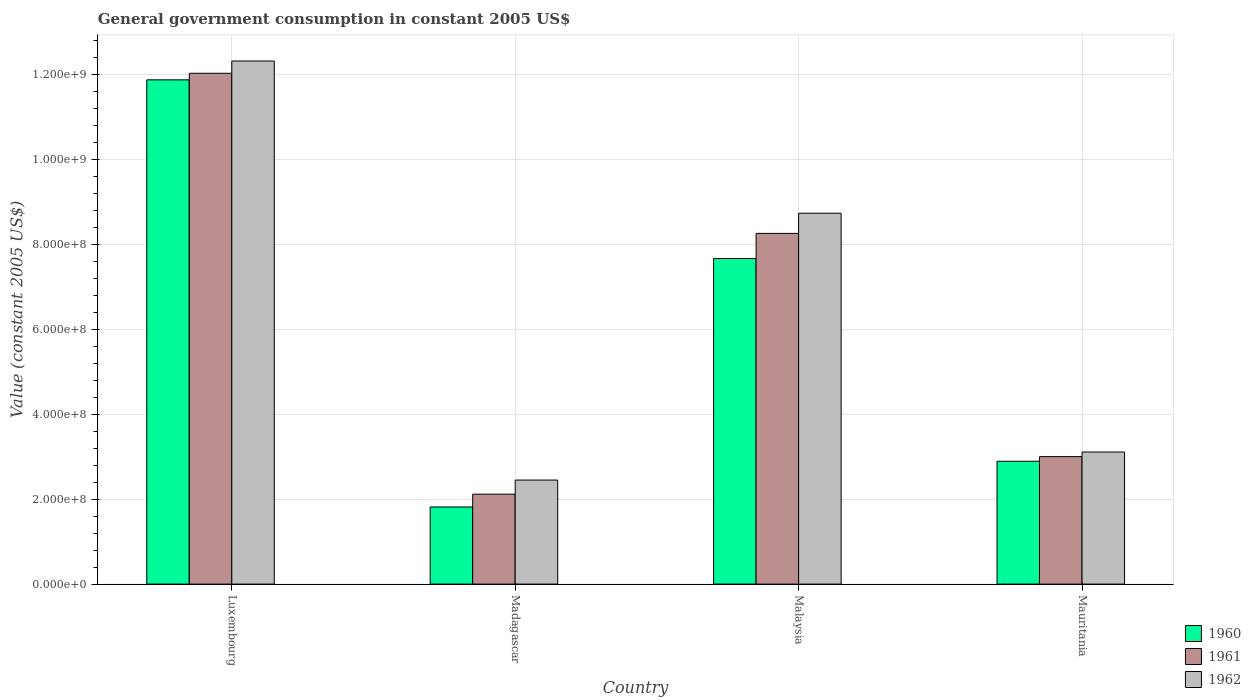Are the number of bars per tick equal to the number of legend labels?
Offer a terse response. Yes. What is the label of the 2nd group of bars from the left?
Make the answer very short. Madagascar. What is the government conusmption in 1960 in Madagascar?
Your answer should be compact. 1.82e+08. Across all countries, what is the maximum government conusmption in 1961?
Provide a succinct answer. 1.20e+09. Across all countries, what is the minimum government conusmption in 1962?
Make the answer very short. 2.45e+08. In which country was the government conusmption in 1961 maximum?
Ensure brevity in your answer.  Luxembourg. In which country was the government conusmption in 1960 minimum?
Ensure brevity in your answer.  Madagascar. What is the total government conusmption in 1962 in the graph?
Your answer should be compact. 2.66e+09. What is the difference between the government conusmption in 1960 in Madagascar and that in Malaysia?
Your answer should be compact. -5.85e+08. What is the difference between the government conusmption in 1960 in Malaysia and the government conusmption in 1962 in Mauritania?
Offer a very short reply. 4.56e+08. What is the average government conusmption in 1961 per country?
Keep it short and to the point. 6.36e+08. What is the difference between the government conusmption of/in 1960 and government conusmption of/in 1961 in Madagascar?
Provide a succinct answer. -3.02e+07. In how many countries, is the government conusmption in 1962 greater than 240000000 US$?
Your answer should be compact. 4. What is the ratio of the government conusmption in 1961 in Luxembourg to that in Mauritania?
Your answer should be very brief. 4.01. What is the difference between the highest and the second highest government conusmption in 1960?
Offer a very short reply. 8.99e+08. What is the difference between the highest and the lowest government conusmption in 1962?
Give a very brief answer. 9.87e+08. In how many countries, is the government conusmption in 1960 greater than the average government conusmption in 1960 taken over all countries?
Your answer should be very brief. 2. What does the 3rd bar from the left in Luxembourg represents?
Your answer should be compact. 1962. What does the 1st bar from the right in Mauritania represents?
Ensure brevity in your answer.  1962. Is it the case that in every country, the sum of the government conusmption in 1960 and government conusmption in 1961 is greater than the government conusmption in 1962?
Keep it short and to the point. Yes. Are all the bars in the graph horizontal?
Provide a succinct answer. No. Does the graph contain grids?
Offer a very short reply. Yes. Where does the legend appear in the graph?
Your answer should be very brief. Bottom right. What is the title of the graph?
Provide a short and direct response. General government consumption in constant 2005 US$. Does "1962" appear as one of the legend labels in the graph?
Your response must be concise. Yes. What is the label or title of the X-axis?
Ensure brevity in your answer.  Country. What is the label or title of the Y-axis?
Keep it short and to the point. Value (constant 2005 US$). What is the Value (constant 2005 US$) in 1960 in Luxembourg?
Your answer should be very brief. 1.19e+09. What is the Value (constant 2005 US$) in 1961 in Luxembourg?
Your answer should be very brief. 1.20e+09. What is the Value (constant 2005 US$) of 1962 in Luxembourg?
Offer a terse response. 1.23e+09. What is the Value (constant 2005 US$) of 1960 in Madagascar?
Ensure brevity in your answer.  1.82e+08. What is the Value (constant 2005 US$) of 1961 in Madagascar?
Offer a terse response. 2.12e+08. What is the Value (constant 2005 US$) of 1962 in Madagascar?
Your answer should be compact. 2.45e+08. What is the Value (constant 2005 US$) in 1960 in Malaysia?
Offer a terse response. 7.67e+08. What is the Value (constant 2005 US$) of 1961 in Malaysia?
Your answer should be very brief. 8.26e+08. What is the Value (constant 2005 US$) in 1962 in Malaysia?
Your answer should be very brief. 8.74e+08. What is the Value (constant 2005 US$) in 1960 in Mauritania?
Offer a very short reply. 2.89e+08. What is the Value (constant 2005 US$) in 1961 in Mauritania?
Make the answer very short. 3.00e+08. What is the Value (constant 2005 US$) of 1962 in Mauritania?
Provide a succinct answer. 3.11e+08. Across all countries, what is the maximum Value (constant 2005 US$) in 1960?
Your answer should be very brief. 1.19e+09. Across all countries, what is the maximum Value (constant 2005 US$) of 1961?
Ensure brevity in your answer.  1.20e+09. Across all countries, what is the maximum Value (constant 2005 US$) in 1962?
Offer a very short reply. 1.23e+09. Across all countries, what is the minimum Value (constant 2005 US$) of 1960?
Make the answer very short. 1.82e+08. Across all countries, what is the minimum Value (constant 2005 US$) of 1961?
Make the answer very short. 2.12e+08. Across all countries, what is the minimum Value (constant 2005 US$) of 1962?
Keep it short and to the point. 2.45e+08. What is the total Value (constant 2005 US$) of 1960 in the graph?
Your answer should be very brief. 2.43e+09. What is the total Value (constant 2005 US$) of 1961 in the graph?
Provide a succinct answer. 2.54e+09. What is the total Value (constant 2005 US$) of 1962 in the graph?
Offer a very short reply. 2.66e+09. What is the difference between the Value (constant 2005 US$) of 1960 in Luxembourg and that in Madagascar?
Offer a terse response. 1.01e+09. What is the difference between the Value (constant 2005 US$) of 1961 in Luxembourg and that in Madagascar?
Your answer should be compact. 9.92e+08. What is the difference between the Value (constant 2005 US$) of 1962 in Luxembourg and that in Madagascar?
Ensure brevity in your answer.  9.87e+08. What is the difference between the Value (constant 2005 US$) in 1960 in Luxembourg and that in Malaysia?
Your answer should be compact. 4.21e+08. What is the difference between the Value (constant 2005 US$) in 1961 in Luxembourg and that in Malaysia?
Offer a very short reply. 3.77e+08. What is the difference between the Value (constant 2005 US$) of 1962 in Luxembourg and that in Malaysia?
Give a very brief answer. 3.59e+08. What is the difference between the Value (constant 2005 US$) of 1960 in Luxembourg and that in Mauritania?
Keep it short and to the point. 8.99e+08. What is the difference between the Value (constant 2005 US$) of 1961 in Luxembourg and that in Mauritania?
Provide a short and direct response. 9.03e+08. What is the difference between the Value (constant 2005 US$) in 1962 in Luxembourg and that in Mauritania?
Your response must be concise. 9.21e+08. What is the difference between the Value (constant 2005 US$) of 1960 in Madagascar and that in Malaysia?
Your answer should be compact. -5.85e+08. What is the difference between the Value (constant 2005 US$) in 1961 in Madagascar and that in Malaysia?
Give a very brief answer. -6.14e+08. What is the difference between the Value (constant 2005 US$) of 1962 in Madagascar and that in Malaysia?
Offer a terse response. -6.29e+08. What is the difference between the Value (constant 2005 US$) of 1960 in Madagascar and that in Mauritania?
Offer a very short reply. -1.08e+08. What is the difference between the Value (constant 2005 US$) in 1961 in Madagascar and that in Mauritania?
Ensure brevity in your answer.  -8.84e+07. What is the difference between the Value (constant 2005 US$) of 1962 in Madagascar and that in Mauritania?
Ensure brevity in your answer.  -6.62e+07. What is the difference between the Value (constant 2005 US$) in 1960 in Malaysia and that in Mauritania?
Provide a short and direct response. 4.78e+08. What is the difference between the Value (constant 2005 US$) in 1961 in Malaysia and that in Mauritania?
Give a very brief answer. 5.26e+08. What is the difference between the Value (constant 2005 US$) of 1962 in Malaysia and that in Mauritania?
Make the answer very short. 5.63e+08. What is the difference between the Value (constant 2005 US$) of 1960 in Luxembourg and the Value (constant 2005 US$) of 1961 in Madagascar?
Provide a short and direct response. 9.76e+08. What is the difference between the Value (constant 2005 US$) in 1960 in Luxembourg and the Value (constant 2005 US$) in 1962 in Madagascar?
Provide a short and direct response. 9.43e+08. What is the difference between the Value (constant 2005 US$) of 1961 in Luxembourg and the Value (constant 2005 US$) of 1962 in Madagascar?
Keep it short and to the point. 9.59e+08. What is the difference between the Value (constant 2005 US$) of 1960 in Luxembourg and the Value (constant 2005 US$) of 1961 in Malaysia?
Your answer should be compact. 3.62e+08. What is the difference between the Value (constant 2005 US$) of 1960 in Luxembourg and the Value (constant 2005 US$) of 1962 in Malaysia?
Your answer should be very brief. 3.14e+08. What is the difference between the Value (constant 2005 US$) of 1961 in Luxembourg and the Value (constant 2005 US$) of 1962 in Malaysia?
Your answer should be very brief. 3.30e+08. What is the difference between the Value (constant 2005 US$) in 1960 in Luxembourg and the Value (constant 2005 US$) in 1961 in Mauritania?
Your answer should be compact. 8.88e+08. What is the difference between the Value (constant 2005 US$) of 1960 in Luxembourg and the Value (constant 2005 US$) of 1962 in Mauritania?
Your answer should be compact. 8.77e+08. What is the difference between the Value (constant 2005 US$) of 1961 in Luxembourg and the Value (constant 2005 US$) of 1962 in Mauritania?
Give a very brief answer. 8.92e+08. What is the difference between the Value (constant 2005 US$) in 1960 in Madagascar and the Value (constant 2005 US$) in 1961 in Malaysia?
Give a very brief answer. -6.45e+08. What is the difference between the Value (constant 2005 US$) of 1960 in Madagascar and the Value (constant 2005 US$) of 1962 in Malaysia?
Make the answer very short. -6.92e+08. What is the difference between the Value (constant 2005 US$) in 1961 in Madagascar and the Value (constant 2005 US$) in 1962 in Malaysia?
Your answer should be compact. -6.62e+08. What is the difference between the Value (constant 2005 US$) of 1960 in Madagascar and the Value (constant 2005 US$) of 1961 in Mauritania?
Give a very brief answer. -1.19e+08. What is the difference between the Value (constant 2005 US$) in 1960 in Madagascar and the Value (constant 2005 US$) in 1962 in Mauritania?
Provide a short and direct response. -1.30e+08. What is the difference between the Value (constant 2005 US$) in 1961 in Madagascar and the Value (constant 2005 US$) in 1962 in Mauritania?
Provide a succinct answer. -9.93e+07. What is the difference between the Value (constant 2005 US$) of 1960 in Malaysia and the Value (constant 2005 US$) of 1961 in Mauritania?
Make the answer very short. 4.67e+08. What is the difference between the Value (constant 2005 US$) of 1960 in Malaysia and the Value (constant 2005 US$) of 1962 in Mauritania?
Provide a succinct answer. 4.56e+08. What is the difference between the Value (constant 2005 US$) in 1961 in Malaysia and the Value (constant 2005 US$) in 1962 in Mauritania?
Ensure brevity in your answer.  5.15e+08. What is the average Value (constant 2005 US$) in 1960 per country?
Your answer should be compact. 6.07e+08. What is the average Value (constant 2005 US$) of 1961 per country?
Provide a succinct answer. 6.36e+08. What is the average Value (constant 2005 US$) in 1962 per country?
Offer a terse response. 6.66e+08. What is the difference between the Value (constant 2005 US$) of 1960 and Value (constant 2005 US$) of 1961 in Luxembourg?
Give a very brief answer. -1.55e+07. What is the difference between the Value (constant 2005 US$) of 1960 and Value (constant 2005 US$) of 1962 in Luxembourg?
Give a very brief answer. -4.43e+07. What is the difference between the Value (constant 2005 US$) of 1961 and Value (constant 2005 US$) of 1962 in Luxembourg?
Your answer should be compact. -2.88e+07. What is the difference between the Value (constant 2005 US$) of 1960 and Value (constant 2005 US$) of 1961 in Madagascar?
Your answer should be compact. -3.02e+07. What is the difference between the Value (constant 2005 US$) of 1960 and Value (constant 2005 US$) of 1962 in Madagascar?
Your answer should be compact. -6.34e+07. What is the difference between the Value (constant 2005 US$) of 1961 and Value (constant 2005 US$) of 1962 in Madagascar?
Offer a terse response. -3.32e+07. What is the difference between the Value (constant 2005 US$) of 1960 and Value (constant 2005 US$) of 1961 in Malaysia?
Offer a terse response. -5.92e+07. What is the difference between the Value (constant 2005 US$) of 1960 and Value (constant 2005 US$) of 1962 in Malaysia?
Your answer should be compact. -1.07e+08. What is the difference between the Value (constant 2005 US$) of 1961 and Value (constant 2005 US$) of 1962 in Malaysia?
Give a very brief answer. -4.75e+07. What is the difference between the Value (constant 2005 US$) in 1960 and Value (constant 2005 US$) in 1961 in Mauritania?
Offer a very short reply. -1.09e+07. What is the difference between the Value (constant 2005 US$) in 1960 and Value (constant 2005 US$) in 1962 in Mauritania?
Ensure brevity in your answer.  -2.18e+07. What is the difference between the Value (constant 2005 US$) of 1961 and Value (constant 2005 US$) of 1962 in Mauritania?
Your answer should be very brief. -1.09e+07. What is the ratio of the Value (constant 2005 US$) of 1960 in Luxembourg to that in Madagascar?
Provide a succinct answer. 6.54. What is the ratio of the Value (constant 2005 US$) of 1961 in Luxembourg to that in Madagascar?
Your answer should be very brief. 5.68. What is the ratio of the Value (constant 2005 US$) of 1962 in Luxembourg to that in Madagascar?
Offer a very short reply. 5.03. What is the ratio of the Value (constant 2005 US$) in 1960 in Luxembourg to that in Malaysia?
Make the answer very short. 1.55. What is the ratio of the Value (constant 2005 US$) in 1961 in Luxembourg to that in Malaysia?
Your answer should be very brief. 1.46. What is the ratio of the Value (constant 2005 US$) of 1962 in Luxembourg to that in Malaysia?
Keep it short and to the point. 1.41. What is the ratio of the Value (constant 2005 US$) in 1960 in Luxembourg to that in Mauritania?
Offer a terse response. 4.11. What is the ratio of the Value (constant 2005 US$) in 1961 in Luxembourg to that in Mauritania?
Make the answer very short. 4.01. What is the ratio of the Value (constant 2005 US$) of 1962 in Luxembourg to that in Mauritania?
Give a very brief answer. 3.96. What is the ratio of the Value (constant 2005 US$) in 1960 in Madagascar to that in Malaysia?
Offer a very short reply. 0.24. What is the ratio of the Value (constant 2005 US$) of 1961 in Madagascar to that in Malaysia?
Make the answer very short. 0.26. What is the ratio of the Value (constant 2005 US$) in 1962 in Madagascar to that in Malaysia?
Make the answer very short. 0.28. What is the ratio of the Value (constant 2005 US$) of 1960 in Madagascar to that in Mauritania?
Make the answer very short. 0.63. What is the ratio of the Value (constant 2005 US$) in 1961 in Madagascar to that in Mauritania?
Provide a succinct answer. 0.71. What is the ratio of the Value (constant 2005 US$) of 1962 in Madagascar to that in Mauritania?
Provide a succinct answer. 0.79. What is the ratio of the Value (constant 2005 US$) in 1960 in Malaysia to that in Mauritania?
Give a very brief answer. 2.65. What is the ratio of the Value (constant 2005 US$) of 1961 in Malaysia to that in Mauritania?
Provide a short and direct response. 2.75. What is the ratio of the Value (constant 2005 US$) of 1962 in Malaysia to that in Mauritania?
Your answer should be very brief. 2.81. What is the difference between the highest and the second highest Value (constant 2005 US$) in 1960?
Provide a short and direct response. 4.21e+08. What is the difference between the highest and the second highest Value (constant 2005 US$) of 1961?
Your answer should be very brief. 3.77e+08. What is the difference between the highest and the second highest Value (constant 2005 US$) in 1962?
Provide a succinct answer. 3.59e+08. What is the difference between the highest and the lowest Value (constant 2005 US$) of 1960?
Offer a terse response. 1.01e+09. What is the difference between the highest and the lowest Value (constant 2005 US$) of 1961?
Keep it short and to the point. 9.92e+08. What is the difference between the highest and the lowest Value (constant 2005 US$) of 1962?
Your answer should be very brief. 9.87e+08. 